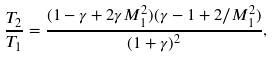Convert formula to latex. <formula><loc_0><loc_0><loc_500><loc_500>\frac { T _ { 2 } } { T _ { 1 } } = \frac { ( 1 - \gamma + 2 \gamma M _ { 1 } ^ { 2 } ) ( \gamma - 1 + 2 / M _ { 1 } ^ { 2 } ) } { ( 1 + \gamma ) ^ { 2 } } ,</formula> 